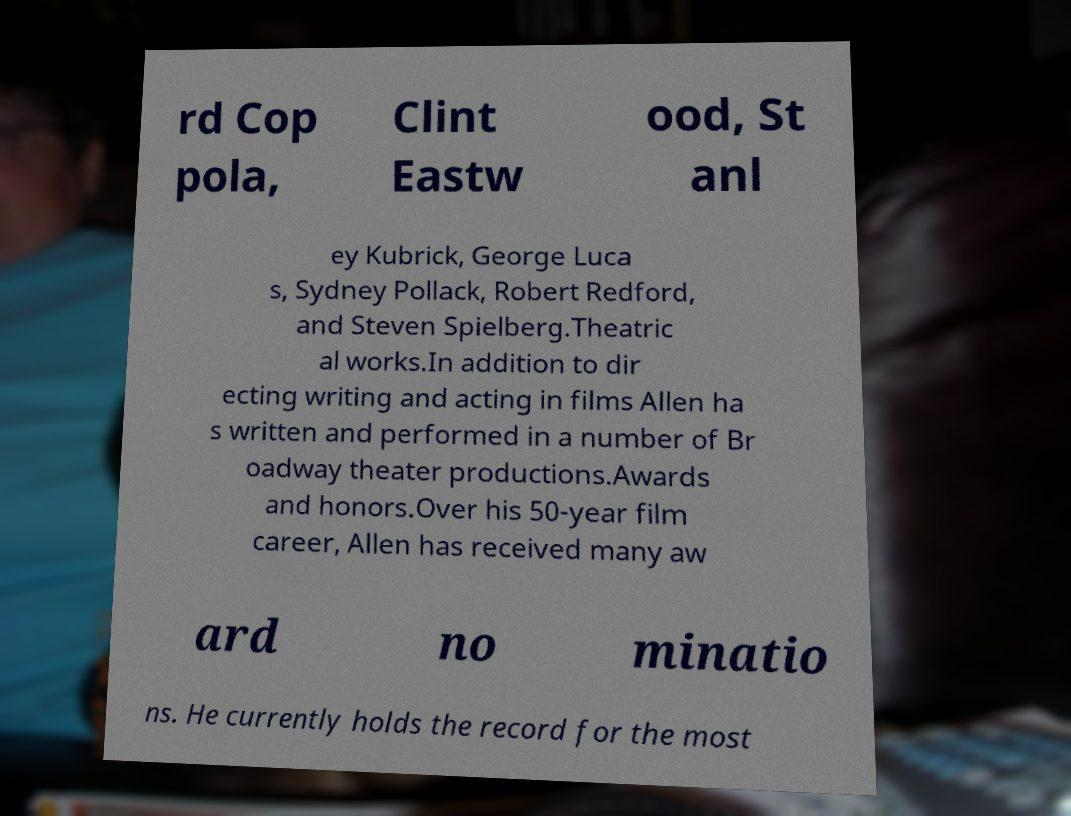Could you extract and type out the text from this image? rd Cop pola, Clint Eastw ood, St anl ey Kubrick, George Luca s, Sydney Pollack, Robert Redford, and Steven Spielberg.Theatric al works.In addition to dir ecting writing and acting in films Allen ha s written and performed in a number of Br oadway theater productions.Awards and honors.Over his 50-year film career, Allen has received many aw ard no minatio ns. He currently holds the record for the most 